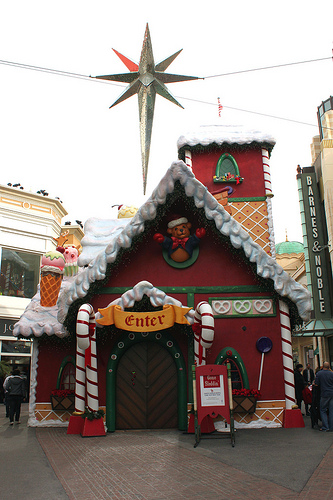<image>
Is the gingerbread house behind the bookstore? No. The gingerbread house is not behind the bookstore. From this viewpoint, the gingerbread house appears to be positioned elsewhere in the scene. 